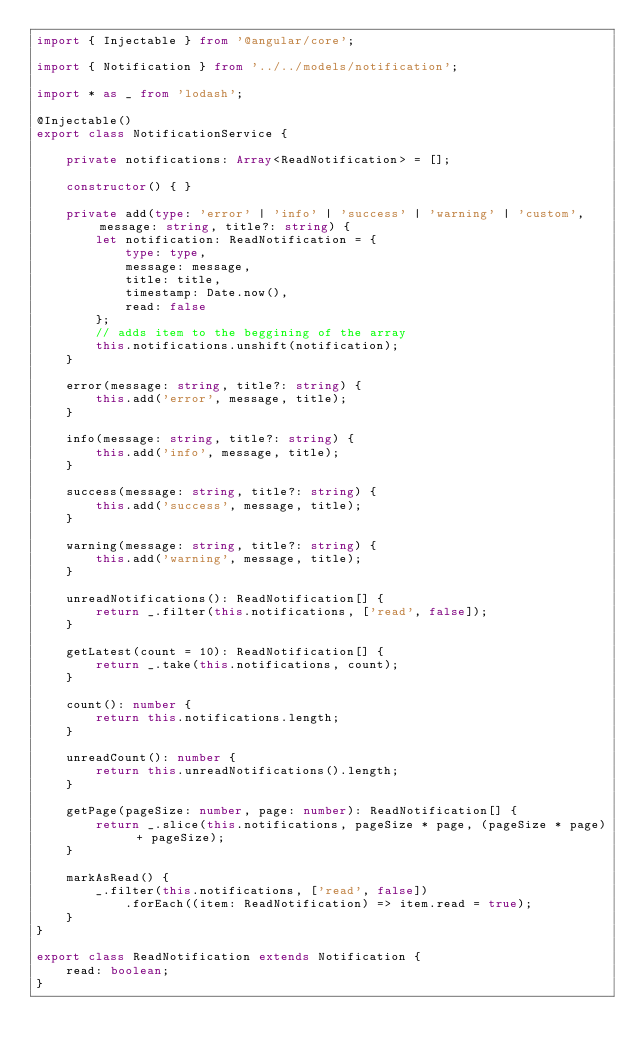<code> <loc_0><loc_0><loc_500><loc_500><_TypeScript_>import { Injectable } from '@angular/core';

import { Notification } from '../../models/notification';

import * as _ from 'lodash';

@Injectable()
export class NotificationService {

    private notifications: Array<ReadNotification> = [];

    constructor() { }

    private add(type: 'error' | 'info' | 'success' | 'warning' | 'custom', message: string, title?: string) {
        let notification: ReadNotification = {
            type: type,
            message: message,
            title: title,
            timestamp: Date.now(),
            read: false
        };
        // adds item to the beggining of the array
        this.notifications.unshift(notification);
    }

    error(message: string, title?: string) {
        this.add('error', message, title);
    }

    info(message: string, title?: string) {
        this.add('info', message, title);
    }

    success(message: string, title?: string) {
        this.add('success', message, title);
    }

    warning(message: string, title?: string) {
        this.add('warning', message, title);
    }

    unreadNotifications(): ReadNotification[] {
        return _.filter(this.notifications, ['read', false]);
    }

    getLatest(count = 10): ReadNotification[] {
        return _.take(this.notifications, count);
    }

    count(): number {
        return this.notifications.length;
    }

    unreadCount(): number {
        return this.unreadNotifications().length;
    }

    getPage(pageSize: number, page: number): ReadNotification[] {
        return _.slice(this.notifications, pageSize * page, (pageSize * page) + pageSize);
    }

    markAsRead() {
        _.filter(this.notifications, ['read', false])
            .forEach((item: ReadNotification) => item.read = true);
    }
}

export class ReadNotification extends Notification {
    read: boolean;
}
</code> 